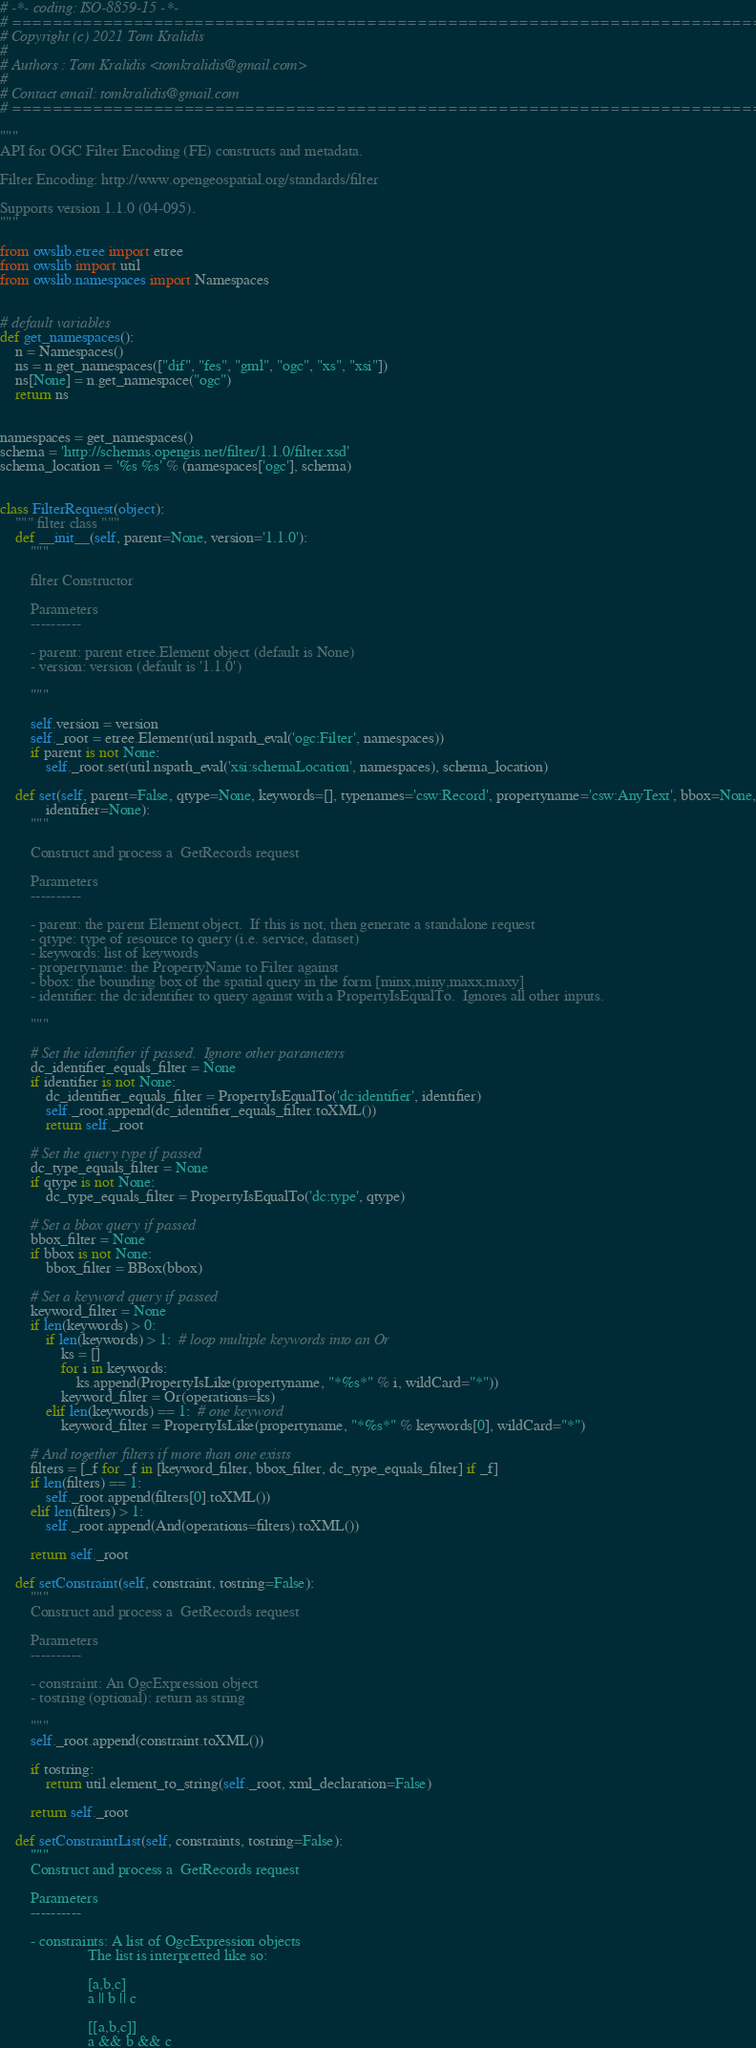<code> <loc_0><loc_0><loc_500><loc_500><_Python_># -*- coding: ISO-8859-15 -*-
# =============================================================================
# Copyright (c) 2021 Tom Kralidis
#
# Authors : Tom Kralidis <tomkralidis@gmail.com>
#
# Contact email: tomkralidis@gmail.com
# =============================================================================

"""
API for OGC Filter Encoding (FE) constructs and metadata.

Filter Encoding: http://www.opengeospatial.org/standards/filter

Supports version 1.1.0 (04-095).
"""

from owslib.etree import etree
from owslib import util
from owslib.namespaces import Namespaces


# default variables
def get_namespaces():
    n = Namespaces()
    ns = n.get_namespaces(["dif", "fes", "gml", "ogc", "xs", "xsi"])
    ns[None] = n.get_namespace("ogc")
    return ns


namespaces = get_namespaces()
schema = 'http://schemas.opengis.net/filter/1.1.0/filter.xsd'
schema_location = '%s %s' % (namespaces['ogc'], schema)


class FilterRequest(object):
    """ filter class """
    def __init__(self, parent=None, version='1.1.0'):
        """

        filter Constructor

        Parameters
        ----------

        - parent: parent etree.Element object (default is None)
        - version: version (default is '1.1.0')

        """

        self.version = version
        self._root = etree.Element(util.nspath_eval('ogc:Filter', namespaces))
        if parent is not None:
            self._root.set(util.nspath_eval('xsi:schemaLocation', namespaces), schema_location)

    def set(self, parent=False, qtype=None, keywords=[], typenames='csw:Record', propertyname='csw:AnyText', bbox=None,
            identifier=None):
        """

        Construct and process a  GetRecords request

        Parameters
        ----------

        - parent: the parent Element object.  If this is not, then generate a standalone request
        - qtype: type of resource to query (i.e. service, dataset)
        - keywords: list of keywords
        - propertyname: the PropertyName to Filter against
        - bbox: the bounding box of the spatial query in the form [minx,miny,maxx,maxy]
        - identifier: the dc:identifier to query against with a PropertyIsEqualTo.  Ignores all other inputs.

        """

        # Set the identifier if passed.  Ignore other parameters
        dc_identifier_equals_filter = None
        if identifier is not None:
            dc_identifier_equals_filter = PropertyIsEqualTo('dc:identifier', identifier)
            self._root.append(dc_identifier_equals_filter.toXML())
            return self._root

        # Set the query type if passed
        dc_type_equals_filter = None
        if qtype is not None:
            dc_type_equals_filter = PropertyIsEqualTo('dc:type', qtype)

        # Set a bbox query if passed
        bbox_filter = None
        if bbox is not None:
            bbox_filter = BBox(bbox)

        # Set a keyword query if passed
        keyword_filter = None
        if len(keywords) > 0:
            if len(keywords) > 1:  # loop multiple keywords into an Or
                ks = []
                for i in keywords:
                    ks.append(PropertyIsLike(propertyname, "*%s*" % i, wildCard="*"))
                keyword_filter = Or(operations=ks)
            elif len(keywords) == 1:  # one keyword
                keyword_filter = PropertyIsLike(propertyname, "*%s*" % keywords[0], wildCard="*")

        # And together filters if more than one exists
        filters = [_f for _f in [keyword_filter, bbox_filter, dc_type_equals_filter] if _f]
        if len(filters) == 1:
            self._root.append(filters[0].toXML())
        elif len(filters) > 1:
            self._root.append(And(operations=filters).toXML())

        return self._root

    def setConstraint(self, constraint, tostring=False):
        """
        Construct and process a  GetRecords request

        Parameters
        ----------

        - constraint: An OgcExpression object
        - tostring (optional): return as string

        """
        self._root.append(constraint.toXML())

        if tostring:
            return util.element_to_string(self._root, xml_declaration=False)

        return self._root

    def setConstraintList(self, constraints, tostring=False):
        """
        Construct and process a  GetRecords request

        Parameters
        ----------

        - constraints: A list of OgcExpression objects
                       The list is interpretted like so:

                       [a,b,c]
                       a || b || c

                       [[a,b,c]]
                       a && b && c
</code> 